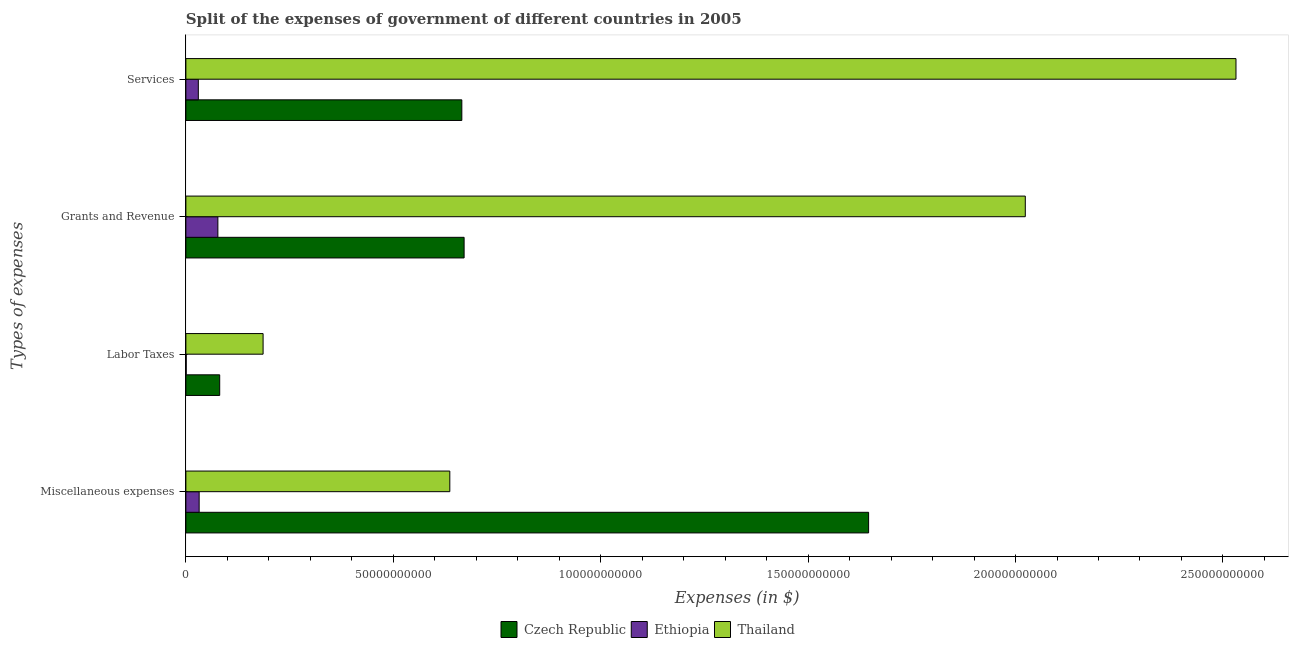How many different coloured bars are there?
Make the answer very short. 3. How many groups of bars are there?
Offer a terse response. 4. Are the number of bars per tick equal to the number of legend labels?
Your response must be concise. Yes. What is the label of the 3rd group of bars from the top?
Provide a short and direct response. Labor Taxes. What is the amount spent on grants and revenue in Ethiopia?
Make the answer very short. 7.71e+09. Across all countries, what is the maximum amount spent on labor taxes?
Your response must be concise. 1.86e+1. Across all countries, what is the minimum amount spent on services?
Offer a very short reply. 3.00e+09. In which country was the amount spent on labor taxes maximum?
Provide a succinct answer. Thailand. In which country was the amount spent on services minimum?
Offer a very short reply. Ethiopia. What is the total amount spent on grants and revenue in the graph?
Ensure brevity in your answer.  2.77e+11. What is the difference between the amount spent on labor taxes in Ethiopia and that in Thailand?
Your response must be concise. -1.85e+1. What is the difference between the amount spent on miscellaneous expenses in Thailand and the amount spent on services in Ethiopia?
Provide a succinct answer. 6.06e+1. What is the average amount spent on labor taxes per country?
Provide a short and direct response. 8.95e+09. What is the difference between the amount spent on labor taxes and amount spent on miscellaneous expenses in Czech Republic?
Your answer should be very brief. -1.56e+11. In how many countries, is the amount spent on labor taxes greater than 200000000000 $?
Ensure brevity in your answer.  0. What is the ratio of the amount spent on miscellaneous expenses in Thailand to that in Czech Republic?
Ensure brevity in your answer.  0.39. Is the amount spent on grants and revenue in Ethiopia less than that in Thailand?
Give a very brief answer. Yes. Is the difference between the amount spent on services in Ethiopia and Thailand greater than the difference between the amount spent on miscellaneous expenses in Ethiopia and Thailand?
Offer a terse response. No. What is the difference between the highest and the second highest amount spent on services?
Ensure brevity in your answer.  1.87e+11. What is the difference between the highest and the lowest amount spent on labor taxes?
Your answer should be very brief. 1.85e+1. In how many countries, is the amount spent on labor taxes greater than the average amount spent on labor taxes taken over all countries?
Ensure brevity in your answer.  1. Is the sum of the amount spent on miscellaneous expenses in Thailand and Ethiopia greater than the maximum amount spent on services across all countries?
Provide a short and direct response. No. What does the 3rd bar from the top in Miscellaneous expenses represents?
Provide a succinct answer. Czech Republic. What does the 3rd bar from the bottom in Services represents?
Keep it short and to the point. Thailand. Are all the bars in the graph horizontal?
Offer a terse response. Yes. How many countries are there in the graph?
Your response must be concise. 3. What is the difference between two consecutive major ticks on the X-axis?
Offer a very short reply. 5.00e+1. How many legend labels are there?
Ensure brevity in your answer.  3. How are the legend labels stacked?
Your answer should be very brief. Horizontal. What is the title of the graph?
Make the answer very short. Split of the expenses of government of different countries in 2005. What is the label or title of the X-axis?
Give a very brief answer. Expenses (in $). What is the label or title of the Y-axis?
Your answer should be compact. Types of expenses. What is the Expenses (in $) of Czech Republic in Miscellaneous expenses?
Keep it short and to the point. 1.65e+11. What is the Expenses (in $) of Ethiopia in Miscellaneous expenses?
Keep it short and to the point. 3.20e+09. What is the Expenses (in $) of Thailand in Miscellaneous expenses?
Provide a succinct answer. 6.36e+1. What is the Expenses (in $) in Czech Republic in Labor Taxes?
Your answer should be compact. 8.15e+09. What is the Expenses (in $) in Ethiopia in Labor Taxes?
Your response must be concise. 7.71e+07. What is the Expenses (in $) in Thailand in Labor Taxes?
Your answer should be very brief. 1.86e+1. What is the Expenses (in $) in Czech Republic in Grants and Revenue?
Provide a succinct answer. 6.71e+1. What is the Expenses (in $) in Ethiopia in Grants and Revenue?
Offer a very short reply. 7.71e+09. What is the Expenses (in $) of Thailand in Grants and Revenue?
Your answer should be very brief. 2.02e+11. What is the Expenses (in $) in Czech Republic in Services?
Your response must be concise. 6.65e+1. What is the Expenses (in $) of Ethiopia in Services?
Make the answer very short. 3.00e+09. What is the Expenses (in $) of Thailand in Services?
Your answer should be very brief. 2.53e+11. Across all Types of expenses, what is the maximum Expenses (in $) in Czech Republic?
Give a very brief answer. 1.65e+11. Across all Types of expenses, what is the maximum Expenses (in $) of Ethiopia?
Your answer should be compact. 7.71e+09. Across all Types of expenses, what is the maximum Expenses (in $) in Thailand?
Provide a short and direct response. 2.53e+11. Across all Types of expenses, what is the minimum Expenses (in $) of Czech Republic?
Your answer should be compact. 8.15e+09. Across all Types of expenses, what is the minimum Expenses (in $) in Ethiopia?
Your answer should be very brief. 7.71e+07. Across all Types of expenses, what is the minimum Expenses (in $) of Thailand?
Offer a terse response. 1.86e+1. What is the total Expenses (in $) in Czech Republic in the graph?
Provide a short and direct response. 3.06e+11. What is the total Expenses (in $) of Ethiopia in the graph?
Your answer should be very brief. 1.40e+1. What is the total Expenses (in $) in Thailand in the graph?
Provide a succinct answer. 5.38e+11. What is the difference between the Expenses (in $) of Czech Republic in Miscellaneous expenses and that in Labor Taxes?
Your answer should be compact. 1.56e+11. What is the difference between the Expenses (in $) of Ethiopia in Miscellaneous expenses and that in Labor Taxes?
Make the answer very short. 3.12e+09. What is the difference between the Expenses (in $) of Thailand in Miscellaneous expenses and that in Labor Taxes?
Offer a very short reply. 4.50e+1. What is the difference between the Expenses (in $) in Czech Republic in Miscellaneous expenses and that in Grants and Revenue?
Ensure brevity in your answer.  9.75e+1. What is the difference between the Expenses (in $) of Ethiopia in Miscellaneous expenses and that in Grants and Revenue?
Offer a terse response. -4.51e+09. What is the difference between the Expenses (in $) in Thailand in Miscellaneous expenses and that in Grants and Revenue?
Keep it short and to the point. -1.39e+11. What is the difference between the Expenses (in $) of Czech Republic in Miscellaneous expenses and that in Services?
Give a very brief answer. 9.81e+1. What is the difference between the Expenses (in $) of Ethiopia in Miscellaneous expenses and that in Services?
Make the answer very short. 2.00e+08. What is the difference between the Expenses (in $) in Thailand in Miscellaneous expenses and that in Services?
Provide a short and direct response. -1.90e+11. What is the difference between the Expenses (in $) in Czech Republic in Labor Taxes and that in Grants and Revenue?
Your answer should be compact. -5.89e+1. What is the difference between the Expenses (in $) of Ethiopia in Labor Taxes and that in Grants and Revenue?
Your response must be concise. -7.64e+09. What is the difference between the Expenses (in $) in Thailand in Labor Taxes and that in Grants and Revenue?
Keep it short and to the point. -1.84e+11. What is the difference between the Expenses (in $) in Czech Republic in Labor Taxes and that in Services?
Offer a terse response. -5.84e+1. What is the difference between the Expenses (in $) of Ethiopia in Labor Taxes and that in Services?
Your answer should be very brief. -2.92e+09. What is the difference between the Expenses (in $) of Thailand in Labor Taxes and that in Services?
Your response must be concise. -2.35e+11. What is the difference between the Expenses (in $) in Czech Republic in Grants and Revenue and that in Services?
Your response must be concise. 5.51e+08. What is the difference between the Expenses (in $) of Ethiopia in Grants and Revenue and that in Services?
Offer a very short reply. 4.71e+09. What is the difference between the Expenses (in $) in Thailand in Grants and Revenue and that in Services?
Ensure brevity in your answer.  -5.08e+1. What is the difference between the Expenses (in $) in Czech Republic in Miscellaneous expenses and the Expenses (in $) in Ethiopia in Labor Taxes?
Provide a succinct answer. 1.65e+11. What is the difference between the Expenses (in $) in Czech Republic in Miscellaneous expenses and the Expenses (in $) in Thailand in Labor Taxes?
Provide a succinct answer. 1.46e+11. What is the difference between the Expenses (in $) in Ethiopia in Miscellaneous expenses and the Expenses (in $) in Thailand in Labor Taxes?
Offer a very short reply. -1.54e+1. What is the difference between the Expenses (in $) of Czech Republic in Miscellaneous expenses and the Expenses (in $) of Ethiopia in Grants and Revenue?
Provide a succinct answer. 1.57e+11. What is the difference between the Expenses (in $) in Czech Republic in Miscellaneous expenses and the Expenses (in $) in Thailand in Grants and Revenue?
Give a very brief answer. -3.78e+1. What is the difference between the Expenses (in $) of Ethiopia in Miscellaneous expenses and the Expenses (in $) of Thailand in Grants and Revenue?
Your response must be concise. -1.99e+11. What is the difference between the Expenses (in $) in Czech Republic in Miscellaneous expenses and the Expenses (in $) in Ethiopia in Services?
Provide a succinct answer. 1.62e+11. What is the difference between the Expenses (in $) in Czech Republic in Miscellaneous expenses and the Expenses (in $) in Thailand in Services?
Provide a succinct answer. -8.86e+1. What is the difference between the Expenses (in $) in Ethiopia in Miscellaneous expenses and the Expenses (in $) in Thailand in Services?
Make the answer very short. -2.50e+11. What is the difference between the Expenses (in $) in Czech Republic in Labor Taxes and the Expenses (in $) in Ethiopia in Grants and Revenue?
Provide a succinct answer. 4.41e+08. What is the difference between the Expenses (in $) in Czech Republic in Labor Taxes and the Expenses (in $) in Thailand in Grants and Revenue?
Provide a succinct answer. -1.94e+11. What is the difference between the Expenses (in $) of Ethiopia in Labor Taxes and the Expenses (in $) of Thailand in Grants and Revenue?
Keep it short and to the point. -2.02e+11. What is the difference between the Expenses (in $) of Czech Republic in Labor Taxes and the Expenses (in $) of Ethiopia in Services?
Offer a terse response. 5.15e+09. What is the difference between the Expenses (in $) in Czech Republic in Labor Taxes and the Expenses (in $) in Thailand in Services?
Make the answer very short. -2.45e+11. What is the difference between the Expenses (in $) in Ethiopia in Labor Taxes and the Expenses (in $) in Thailand in Services?
Ensure brevity in your answer.  -2.53e+11. What is the difference between the Expenses (in $) in Czech Republic in Grants and Revenue and the Expenses (in $) in Ethiopia in Services?
Provide a short and direct response. 6.41e+1. What is the difference between the Expenses (in $) of Czech Republic in Grants and Revenue and the Expenses (in $) of Thailand in Services?
Keep it short and to the point. -1.86e+11. What is the difference between the Expenses (in $) in Ethiopia in Grants and Revenue and the Expenses (in $) in Thailand in Services?
Your response must be concise. -2.45e+11. What is the average Expenses (in $) of Czech Republic per Types of expenses?
Provide a short and direct response. 7.66e+1. What is the average Expenses (in $) of Ethiopia per Types of expenses?
Keep it short and to the point. 3.50e+09. What is the average Expenses (in $) in Thailand per Types of expenses?
Ensure brevity in your answer.  1.34e+11. What is the difference between the Expenses (in $) in Czech Republic and Expenses (in $) in Ethiopia in Miscellaneous expenses?
Provide a short and direct response. 1.61e+11. What is the difference between the Expenses (in $) of Czech Republic and Expenses (in $) of Thailand in Miscellaneous expenses?
Give a very brief answer. 1.01e+11. What is the difference between the Expenses (in $) in Ethiopia and Expenses (in $) in Thailand in Miscellaneous expenses?
Keep it short and to the point. -6.04e+1. What is the difference between the Expenses (in $) of Czech Republic and Expenses (in $) of Ethiopia in Labor Taxes?
Offer a terse response. 8.08e+09. What is the difference between the Expenses (in $) in Czech Republic and Expenses (in $) in Thailand in Labor Taxes?
Your response must be concise. -1.05e+1. What is the difference between the Expenses (in $) of Ethiopia and Expenses (in $) of Thailand in Labor Taxes?
Offer a terse response. -1.85e+1. What is the difference between the Expenses (in $) of Czech Republic and Expenses (in $) of Ethiopia in Grants and Revenue?
Offer a very short reply. 5.94e+1. What is the difference between the Expenses (in $) in Czech Republic and Expenses (in $) in Thailand in Grants and Revenue?
Ensure brevity in your answer.  -1.35e+11. What is the difference between the Expenses (in $) of Ethiopia and Expenses (in $) of Thailand in Grants and Revenue?
Ensure brevity in your answer.  -1.95e+11. What is the difference between the Expenses (in $) in Czech Republic and Expenses (in $) in Ethiopia in Services?
Your answer should be compact. 6.35e+1. What is the difference between the Expenses (in $) in Czech Republic and Expenses (in $) in Thailand in Services?
Your answer should be very brief. -1.87e+11. What is the difference between the Expenses (in $) of Ethiopia and Expenses (in $) of Thailand in Services?
Ensure brevity in your answer.  -2.50e+11. What is the ratio of the Expenses (in $) in Czech Republic in Miscellaneous expenses to that in Labor Taxes?
Offer a terse response. 20.19. What is the ratio of the Expenses (in $) in Ethiopia in Miscellaneous expenses to that in Labor Taxes?
Your response must be concise. 41.5. What is the ratio of the Expenses (in $) of Thailand in Miscellaneous expenses to that in Labor Taxes?
Your answer should be very brief. 3.42. What is the ratio of the Expenses (in $) of Czech Republic in Miscellaneous expenses to that in Grants and Revenue?
Provide a succinct answer. 2.45. What is the ratio of the Expenses (in $) in Ethiopia in Miscellaneous expenses to that in Grants and Revenue?
Offer a terse response. 0.41. What is the ratio of the Expenses (in $) in Thailand in Miscellaneous expenses to that in Grants and Revenue?
Offer a terse response. 0.31. What is the ratio of the Expenses (in $) in Czech Republic in Miscellaneous expenses to that in Services?
Offer a terse response. 2.47. What is the ratio of the Expenses (in $) in Ethiopia in Miscellaneous expenses to that in Services?
Provide a short and direct response. 1.07. What is the ratio of the Expenses (in $) in Thailand in Miscellaneous expenses to that in Services?
Provide a short and direct response. 0.25. What is the ratio of the Expenses (in $) of Czech Republic in Labor Taxes to that in Grants and Revenue?
Your answer should be very brief. 0.12. What is the ratio of the Expenses (in $) of Ethiopia in Labor Taxes to that in Grants and Revenue?
Ensure brevity in your answer.  0.01. What is the ratio of the Expenses (in $) in Thailand in Labor Taxes to that in Grants and Revenue?
Provide a succinct answer. 0.09. What is the ratio of the Expenses (in $) in Czech Republic in Labor Taxes to that in Services?
Your answer should be compact. 0.12. What is the ratio of the Expenses (in $) in Ethiopia in Labor Taxes to that in Services?
Your response must be concise. 0.03. What is the ratio of the Expenses (in $) in Thailand in Labor Taxes to that in Services?
Provide a succinct answer. 0.07. What is the ratio of the Expenses (in $) in Czech Republic in Grants and Revenue to that in Services?
Provide a succinct answer. 1.01. What is the ratio of the Expenses (in $) of Ethiopia in Grants and Revenue to that in Services?
Provide a short and direct response. 2.57. What is the ratio of the Expenses (in $) of Thailand in Grants and Revenue to that in Services?
Make the answer very short. 0.8. What is the difference between the highest and the second highest Expenses (in $) in Czech Republic?
Give a very brief answer. 9.75e+1. What is the difference between the highest and the second highest Expenses (in $) in Ethiopia?
Offer a very short reply. 4.51e+09. What is the difference between the highest and the second highest Expenses (in $) of Thailand?
Give a very brief answer. 5.08e+1. What is the difference between the highest and the lowest Expenses (in $) of Czech Republic?
Your answer should be compact. 1.56e+11. What is the difference between the highest and the lowest Expenses (in $) of Ethiopia?
Give a very brief answer. 7.64e+09. What is the difference between the highest and the lowest Expenses (in $) in Thailand?
Your answer should be compact. 2.35e+11. 